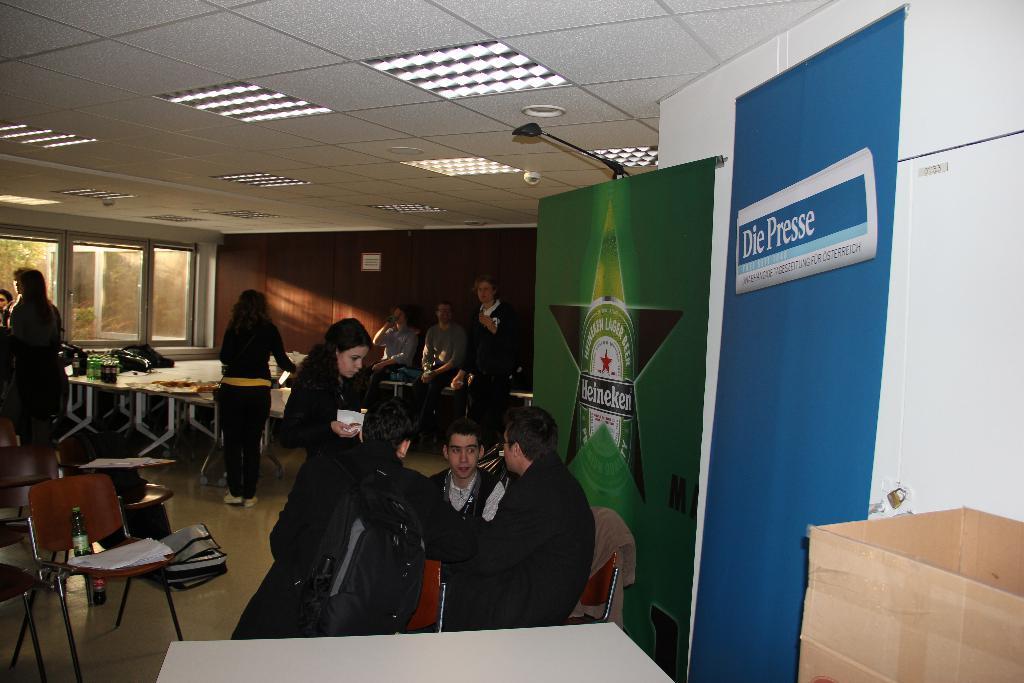Can you describe this image briefly? In this picture there are group of people those who are sitting on the chairs around the table, some are standing at the left side of the image and there are windows at the left side of the image. 